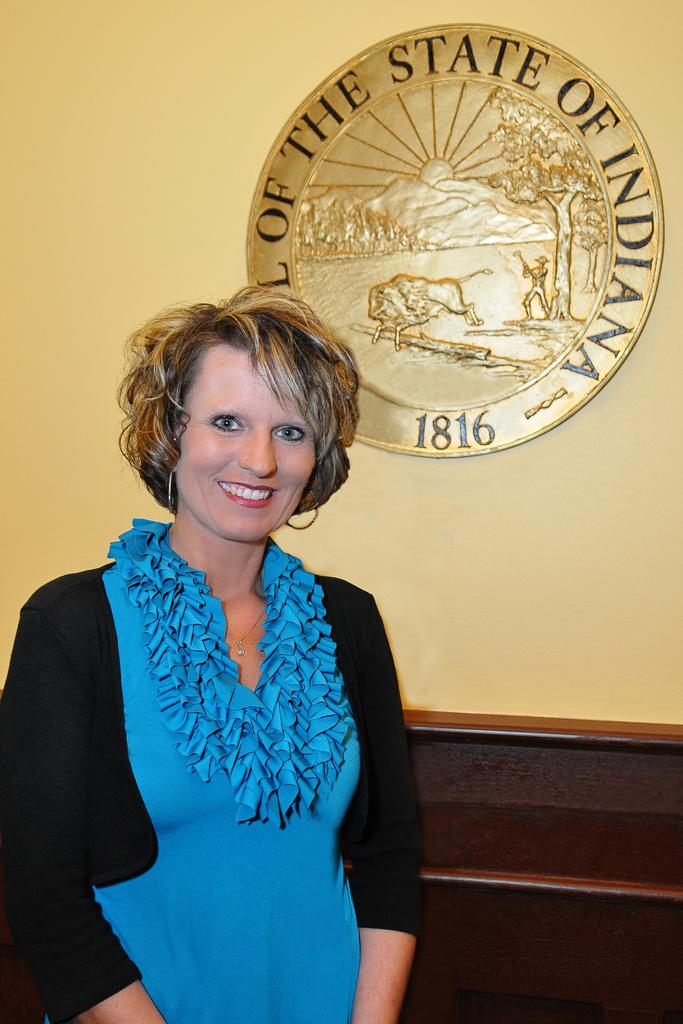What is the woman doing in the image? The woman is standing and smiling in the image. What can be seen on the wall behind the woman? There is a shield on the wall. What is located behind the woman? There is a table behind the woman. What is the name of the woman in the image? The provided facts do not mention the name of the woman, so it cannot be determined from the image. Is the woman sleeping in the image? No, the woman is standing and smiling, not sleeping, in the image. 